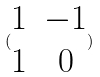Convert formula to latex. <formula><loc_0><loc_0><loc_500><loc_500>( \begin{matrix} 1 & - 1 \\ 1 & 0 \end{matrix} )</formula> 